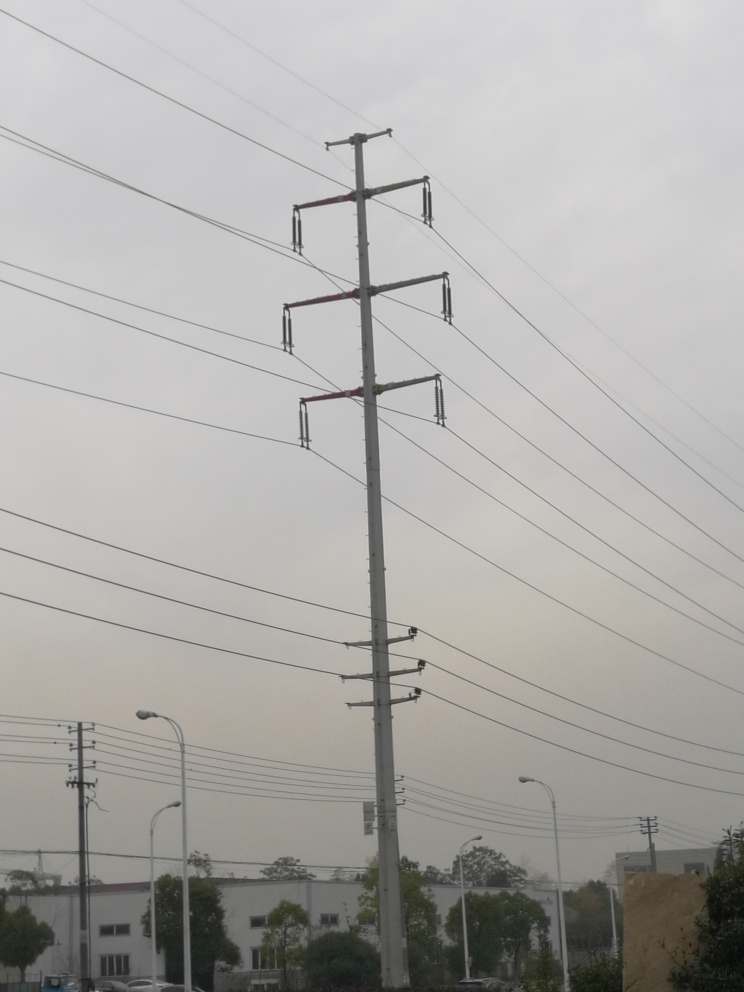What is the weather like in this image? The weather looks overcast with a possibility of fog or haze, resulting in lower visibility and a diffuse quality of light, which obscures distant details. 